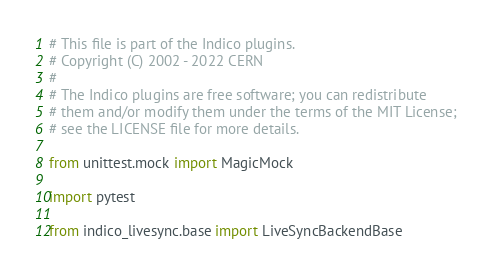<code> <loc_0><loc_0><loc_500><loc_500><_Python_># This file is part of the Indico plugins.
# Copyright (C) 2002 - 2022 CERN
#
# The Indico plugins are free software; you can redistribute
# them and/or modify them under the terms of the MIT License;
# see the LICENSE file for more details.

from unittest.mock import MagicMock

import pytest

from indico_livesync.base import LiveSyncBackendBase</code> 